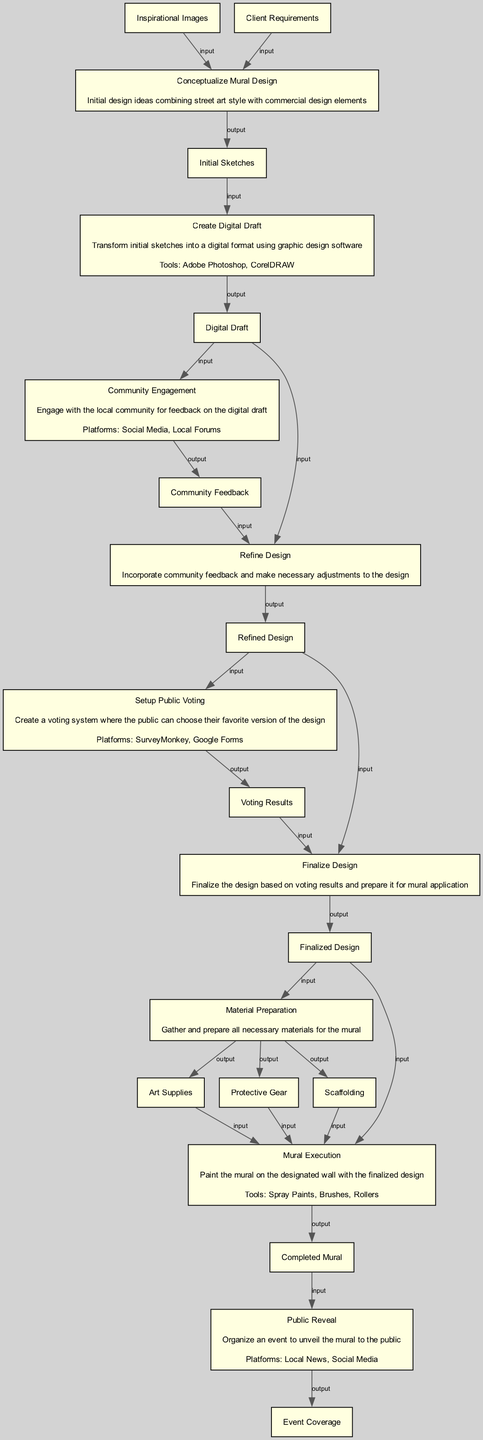What is the first node in the diagram? The first node is "Conceptualize Mural Design" as it is the starting point of the process and has no input dependencies.
Answer: Conceptualize Mural Design How many nodes are there in total? Counting all distinct steps from the beginning to the end leads to a total of 9 nodes in the diagram.
Answer: 9 What is the output of the "Setup Public Voting" step? The output of the "Setup Public Voting" step is "Voting Results," which indicates the outcome of the public voting process.
Answer: Voting Results Which tools are used in the "Create Digital Draft" step? In the "Create Digital Draft" step, the tools specified are "Adobe Photoshop" and "CorelDRAW," which are used for graphic design tasks.
Answer: Adobe Photoshop, CorelDRAW What is the input to the "Refine Design" node? The inputs to the "Refine Design" node consist of "Digital Draft" and "Community Feedback," which are required to enhance the design process.
Answer: Digital Draft, Community Feedback What platforms are used for "Community Engagement"? The platforms specified for "Community Engagement" include "Social Media" and "Local Forums" where feedback is gathered from the community.
Answer: Social Media, Local Forums What is the final output of the process? The final output of the process is "Completed Mural," which signifies that the mural has been entirely painted and is ready for public reveal.
Answer: Completed Mural Which step follows the "Material Preparation"? The step that follows "Material Preparation" is "Mural Execution," which entails painting the mural using the prepared materials.
Answer: Mural Execution What input does the "Finalize Design" require? The "Finalize Design" step requires two inputs: "Refined Design" and "Voting Results," indicating that both aspects are needed to conclude the design process.
Answer: Refined Design, Voting Results 